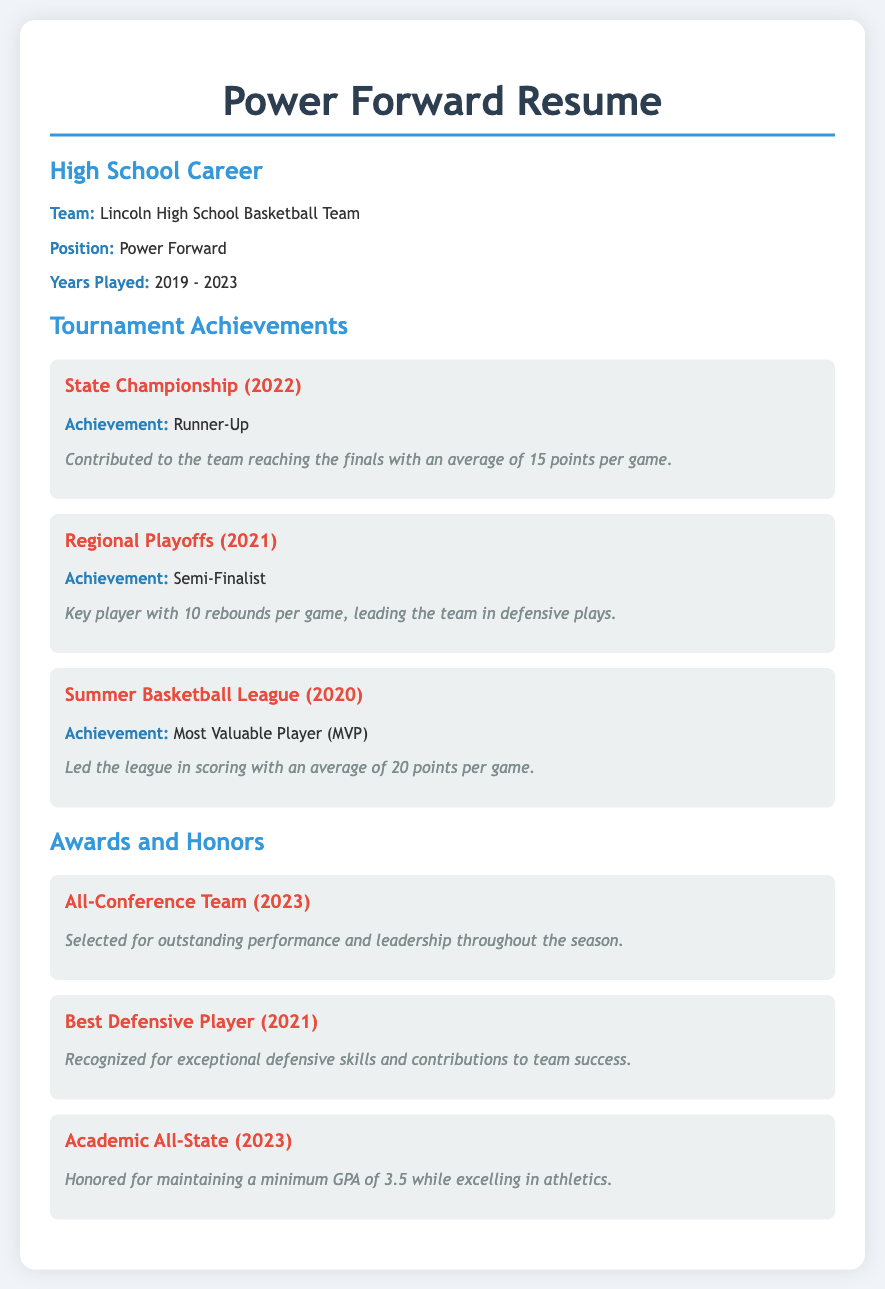What was the team's placement in the State Championship? The State Championship document states that the team was the Runner-Up in 2022.
Answer: Runner-Up What year did the player win the MVP award? The Summer Basketball League section indicates that the MVP award was won in 2020.
Answer: 2020 How many points per game did the player average in the State Championship? The document mentions that the player contributed with an average of 15 points per game in the State Championship.
Answer: 15 points What honor did the player receive in 2023 for academics? The Awards section highlights that the player received the Academic All-State honor for maintaining a GPA of 3.5.
Answer: Academic All-State What was the player's achievement in the Regional Playoffs? The document specifies the achievement of reaching the Semi-Finals in the Regional Playoffs in 2021.
Answer: Semi-Finalist Which award recognizes defensive skills? The Best Defensive Player award in 2021 acknowledges exceptional defensive skills and contributions to team success.
Answer: Best Defensive Player How many years did the player participate in high school basketball? The document states that the player played from 2019 to 2023, which totals four years.
Answer: 4 years What position did the player hold on the basketball team? The document clearly states that the position of the player was Power Forward.
Answer: Power Forward How many rebounds per game did the player average in the Regional Playoffs? The details indicate that the player averaged 10 rebounds per game during the Regional Playoffs.
Answer: 10 rebounds 